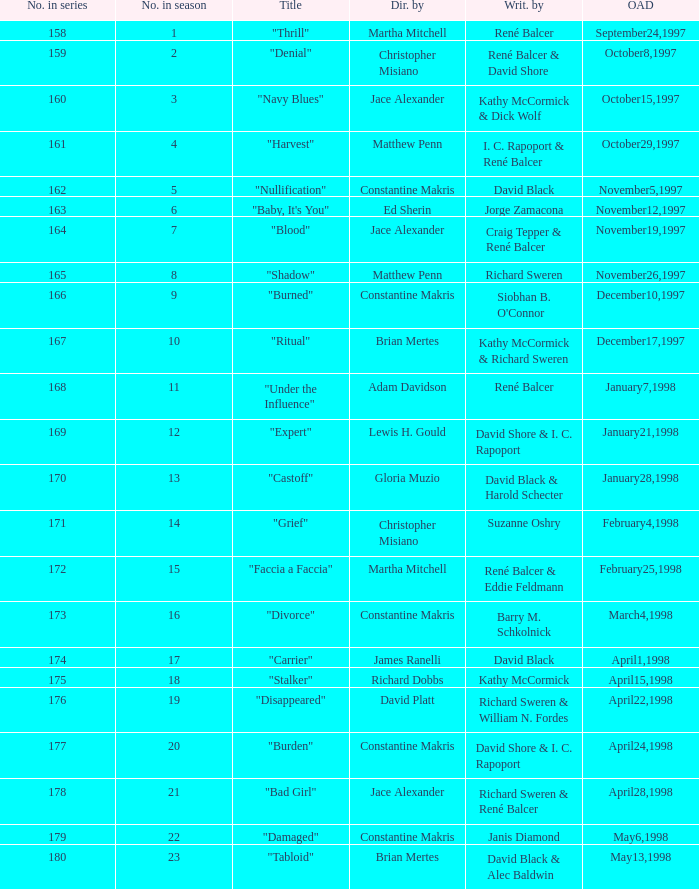The first episode in this season had what number in the series?  158.0. 